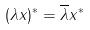Convert formula to latex. <formula><loc_0><loc_0><loc_500><loc_500>( \lambda x ) ^ { * } = \overline { \lambda } x ^ { * }</formula> 